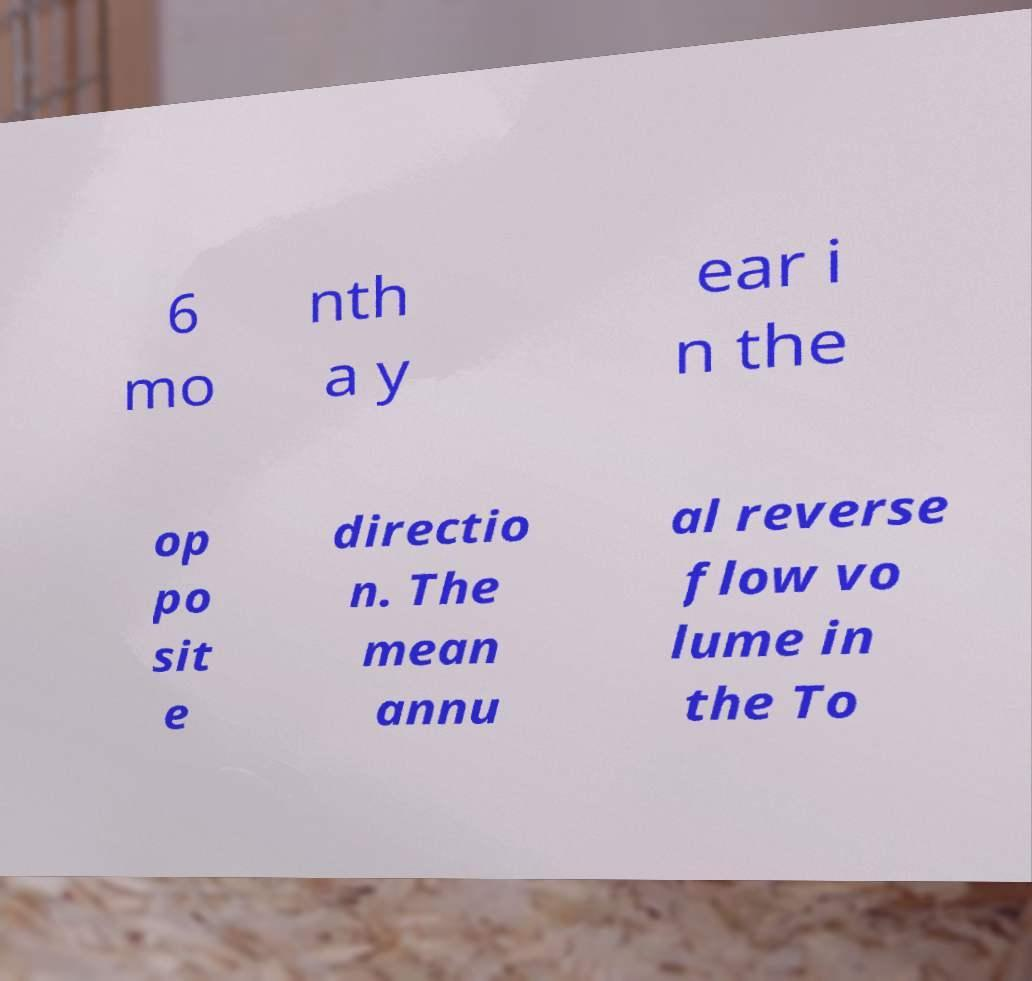There's text embedded in this image that I need extracted. Can you transcribe it verbatim? 6 mo nth a y ear i n the op po sit e directio n. The mean annu al reverse flow vo lume in the To 